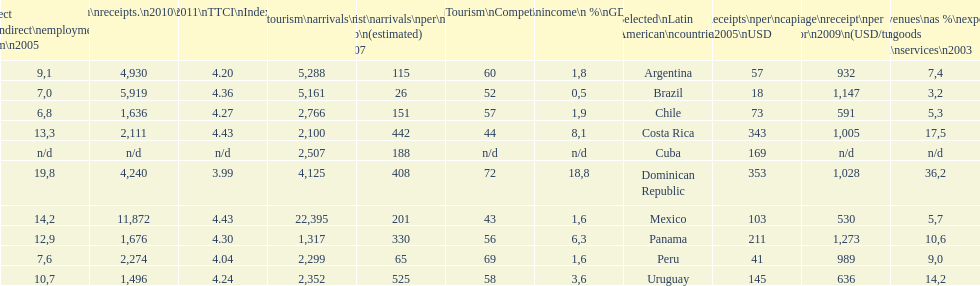How many international tourism arrivals in 2010(x1000) did mexico have? 22,395. 